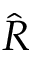Convert formula to latex. <formula><loc_0><loc_0><loc_500><loc_500>\hat { R }</formula> 